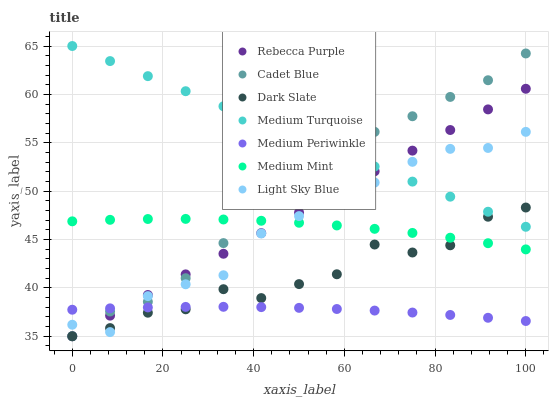Does Medium Periwinkle have the minimum area under the curve?
Answer yes or no. Yes. Does Medium Turquoise have the maximum area under the curve?
Answer yes or no. Yes. Does Cadet Blue have the minimum area under the curve?
Answer yes or no. No. Does Cadet Blue have the maximum area under the curve?
Answer yes or no. No. Is Rebecca Purple the smoothest?
Answer yes or no. Yes. Is Dark Slate the roughest?
Answer yes or no. Yes. Is Cadet Blue the smoothest?
Answer yes or no. No. Is Cadet Blue the roughest?
Answer yes or no. No. Does Cadet Blue have the lowest value?
Answer yes or no. Yes. Does Medium Periwinkle have the lowest value?
Answer yes or no. No. Does Medium Turquoise have the highest value?
Answer yes or no. Yes. Does Cadet Blue have the highest value?
Answer yes or no. No. Is Medium Mint less than Medium Turquoise?
Answer yes or no. Yes. Is Medium Turquoise greater than Medium Periwinkle?
Answer yes or no. Yes. Does Medium Mint intersect Rebecca Purple?
Answer yes or no. Yes. Is Medium Mint less than Rebecca Purple?
Answer yes or no. No. Is Medium Mint greater than Rebecca Purple?
Answer yes or no. No. Does Medium Mint intersect Medium Turquoise?
Answer yes or no. No. 